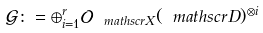<formula> <loc_0><loc_0><loc_500><loc_500>\mathcal { G } \colon = \oplus _ { i = 1 } ^ { r } \mathcal { O } _ { \ m a t h s c r { X } } ( \ m a t h s c r { D } ) ^ { \otimes i }</formula> 